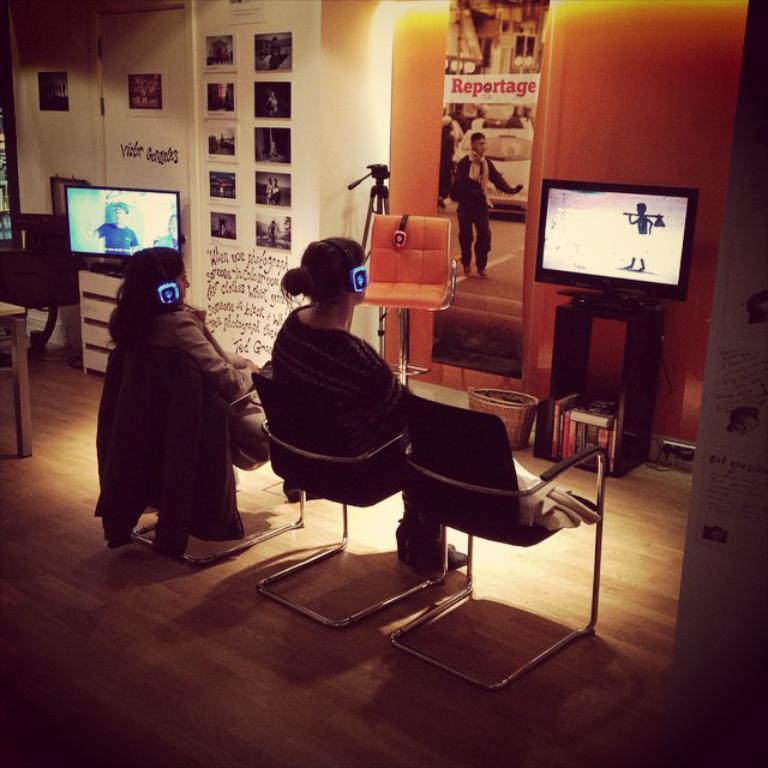Please provide a concise description of this image. In this image there are two women sitting on chairs are watching a monitor in front of them, beside the monitor there is a chair and a camera stand, beside the camera stand, there is another monitor on the table, behind the monitor there are a few pictures and text written on the wall. 